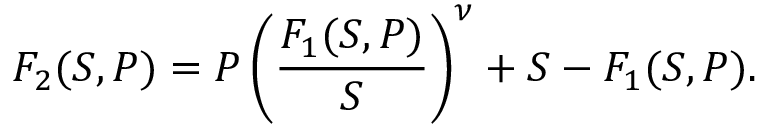<formula> <loc_0><loc_0><loc_500><loc_500>F _ { 2 } ( S , P ) = P \left ( \frac { F _ { 1 } ( S , P ) } { S } \right ) ^ { \nu } + S - F _ { 1 } ( S , P ) .</formula> 